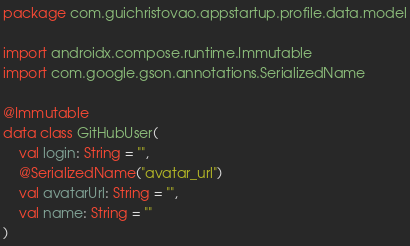<code> <loc_0><loc_0><loc_500><loc_500><_Kotlin_>package com.guichristovao.appstartup.profile.data.model

import androidx.compose.runtime.Immutable
import com.google.gson.annotations.SerializedName

@Immutable
data class GitHubUser(
    val login: String = "",
    @SerializedName("avatar_url")
    val avatarUrl: String = "",
    val name: String = ""
)
</code> 